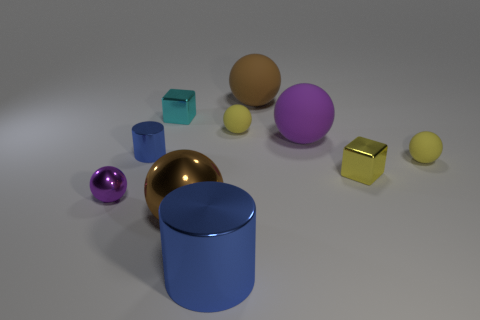Subtract 1 balls. How many balls are left? 5 Subtract all large brown rubber spheres. How many spheres are left? 5 Subtract all green spheres. Subtract all red cylinders. How many spheres are left? 6 Subtract all blocks. How many objects are left? 8 Subtract all blue objects. Subtract all cyan things. How many objects are left? 7 Add 1 cubes. How many cubes are left? 3 Add 3 blocks. How many blocks exist? 5 Subtract 1 blue cylinders. How many objects are left? 9 